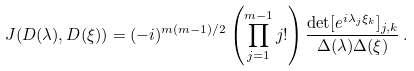Convert formula to latex. <formula><loc_0><loc_0><loc_500><loc_500>J ( D ( \lambda ) , D ( \xi ) ) = ( - i ) ^ { m ( m - 1 ) / 2 } \left ( { \prod _ { j = 1 } ^ { m - 1 } j ! } \right ) \frac { \det [ e ^ { i \lambda _ { j } \xi _ { k } } ] _ { j , k } } { \Delta ( \lambda ) \Delta ( \xi ) } \, .</formula> 